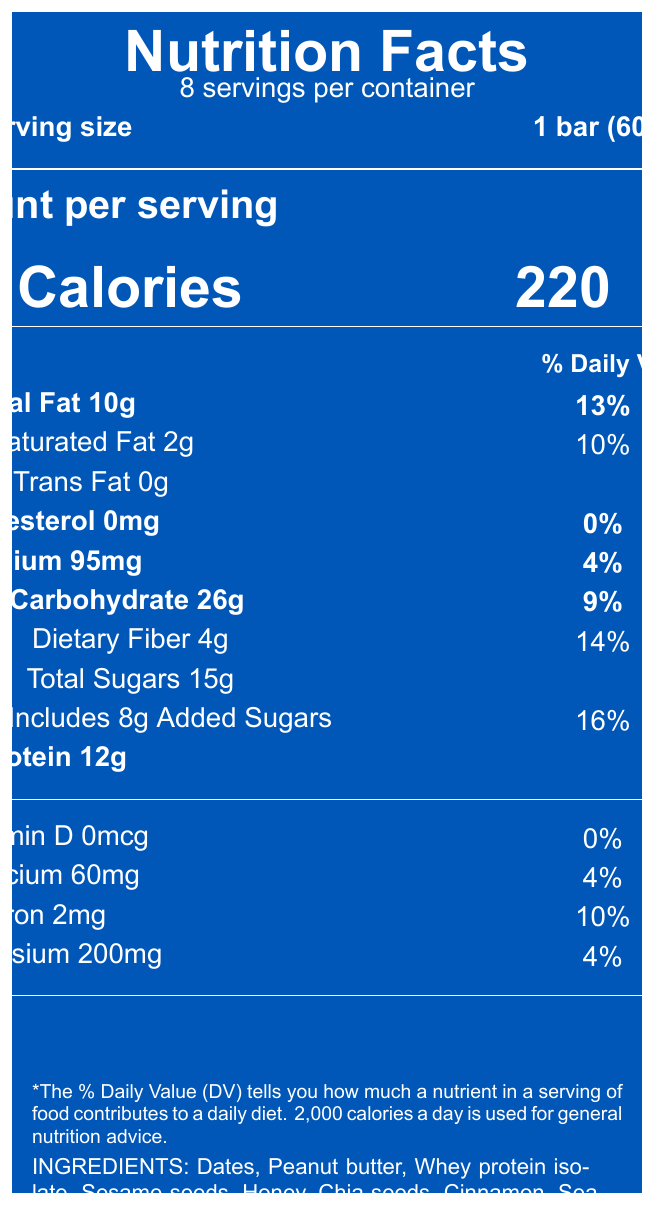what is the serving size? The serving size is explicitly stated as "1 bar (60g)" near the top of the document.
Answer: 1 bar (60g) how many servings are in a container? The document states "8 servings per container" immediately below the Nutrition Facts title.
Answer: 8 how many calories are in one serving? The amount of calories per serving is presented clearly in large font as "Calories 220".
Answer: 220 what is the total fat content per serving? The document lists "Total Fat 10g" under the nutrition facts.
Answer: 10g what percentage of the daily value is the calcium content? The daily value percentage for calcium is stated as "4%" next to the amount of "60mg".
Answer: 4% what are some of the main ingredients in the protein bar? A. Almonds B. Dates C. Whey protein isolate D. Sesame seeds The document lists "Dates", "Whey protein isolate", and "Sesame seeds" but does not mention almonds.
Answer: B, C, D which of the following does the product contain? A. Sea salt B. Sugar C. Artificial sweeteners D. Chia seeds The document lists "Sea salt" and "Chia seeds" in the ingredients but explicitly states "No artificial sweeteners or preservatives".
Answer: A, D is the product halal-certified? The document mentions "Certified Halal by the Islamic Food and Nutrition Council of America."
Answer: Yes summarize the main idea of the document The document contains various sections conveying the nutritional values, ingredients, serving size, and additional credential information about the Somali-Inspired Protein Bar. It highlights its use of Somali cuisine staples and caters to individuals looking to maintain a connection to their cultural roots.
Answer: The document provides the nutritional information and ingredients of a Somali-Inspired Protein Bar, highlighting key nutritional details, such as calories, fat content, protein, and vitamins, as well as the presence of traditional Somali ingredients. It also mentions allergen information, halal certification, and its production location. what is the amount of protein in one serving? The document states "Protein 12g" under the nutritional facts section.
Answer: 12g how much dietary fiber does one serving of the protein bar contain? The dietary fiber content is specified as "Dietary Fiber 4g" in the nutritional information.
Answer: 4g how much potassium is in each serving? The amount of potassium in one serving is mentioned as "Potassium 200mg".
Answer: 200mg what is the cholesterol content per serving? The cholesterol content is listed as "Cholesterol 0mg" in the document.
Answer: 0mg what does the allergen information state? The allergen information section specifies these details plainly.
Answer: Contains peanuts and milk. May contain traces of tree nuts and sesame. how much-added sugars does one serving contain? The document indicates that "Includes 8g Added Sugars".
Answer: 8g where is the product manufactured? A. Minneapolis, Minnesota B. New York, New York C. Los Angeles, California D. Chicago, Illinois The document states "Produced in Minneapolis, Minnesota, USA."
Answer: A what is the iron content in the protein bar? A. 4mg B. 2mg C. 3mg D. 1mg The document lists "Iron 2mg" under the nutritional content.
Answer: B who certified the product as halal? The document mentions "Certified Halal by the Islamic Food and Nutrition Council of America."
Answer: The Islamic Food and Nutrition Council of America can we determine the amount of Vitamin C in the protein bar? The document does not provide any information regarding the Vitamin C content.
Answer: Cannot be determined does one serving of the protein bar contain trans fat? The document mentions "Trans Fat 0g," indicating that there is no trans fat in one serving.
Answer: No 